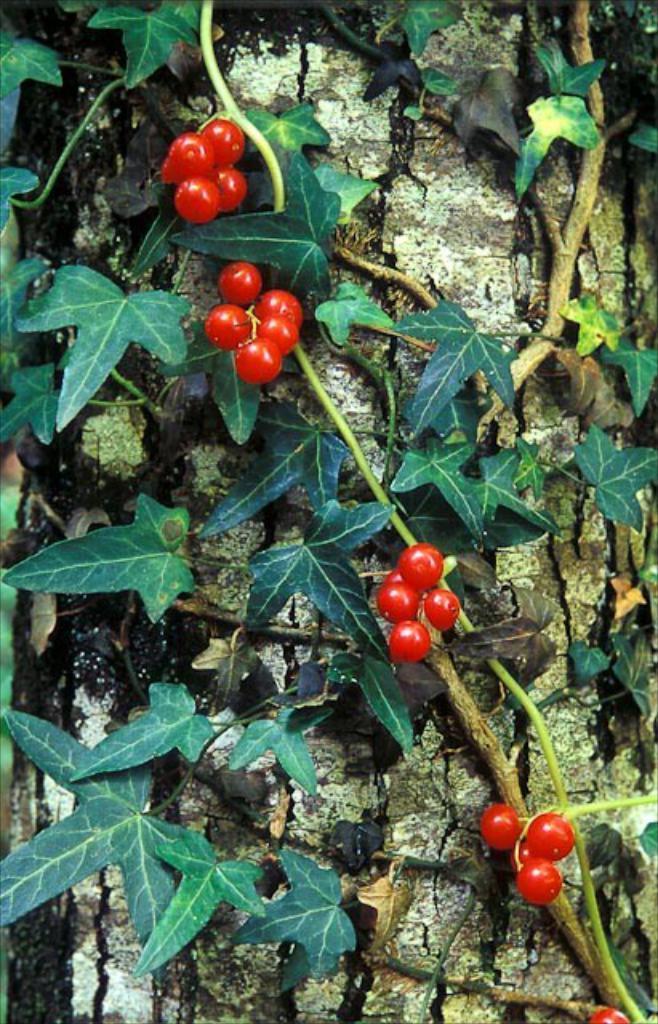Can you describe this image briefly? In this image we can see there are plants attached to the trunk and there is a red color object looks like a cherry. 